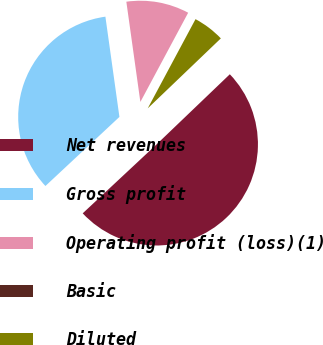Convert chart to OTSL. <chart><loc_0><loc_0><loc_500><loc_500><pie_chart><fcel>Net revenues<fcel>Gross profit<fcel>Operating profit (loss)(1)<fcel>Basic<fcel>Diluted<nl><fcel>50.2%<fcel>34.74%<fcel>10.04%<fcel>0.0%<fcel>5.02%<nl></chart> 